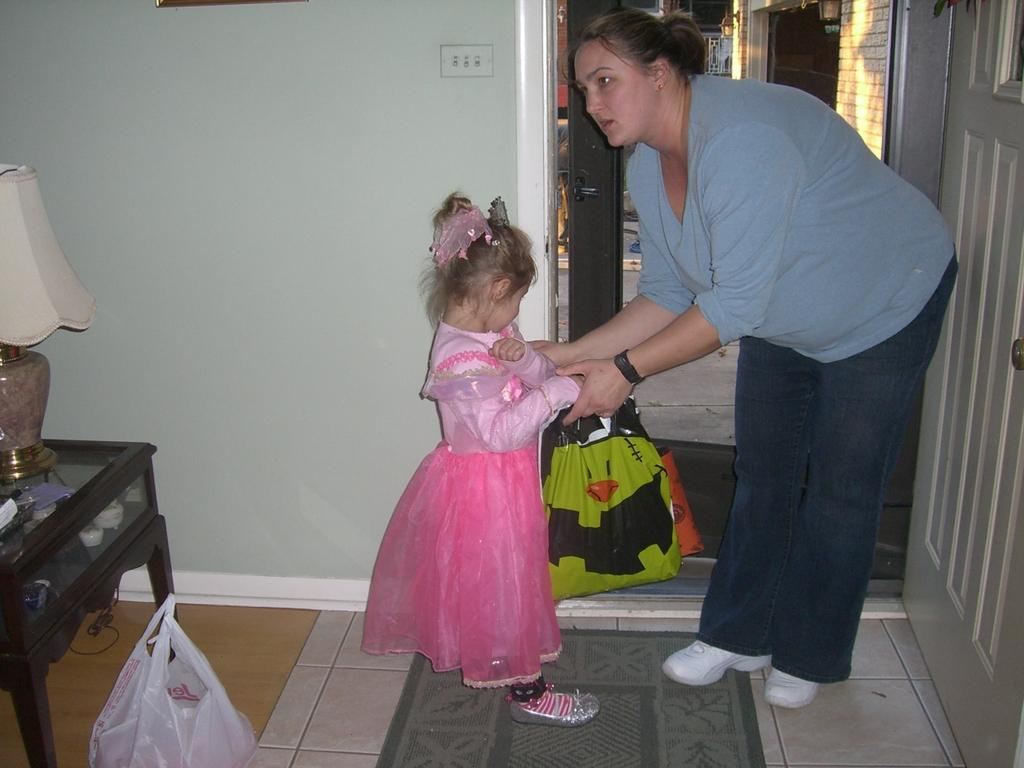Who are the people in the image? There is a woman and a girl in the image. How are the woman and the girl positioned in relation to each other? The woman and the girl are standing opposite to each other. What is the woman holding in the image? The woman is carrying a carry bag. How many horses are present in the image? There are no horses present in the image. What type of mitten is the woman wearing in the image? The woman is not wearing a mitten in the image. 